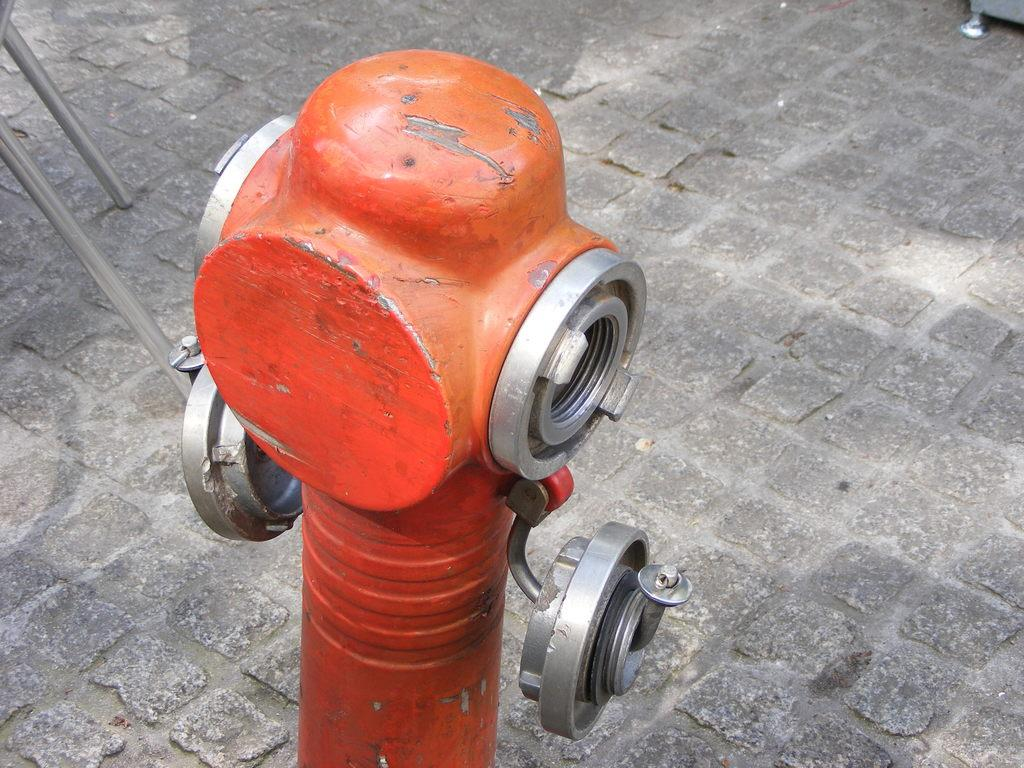Where was the image taken? The image was clicked outside. What is the prominent object in the foreground of the image? There is an orange color metal object in the foreground, which appears to be a water hydrant. What can be seen on the left side of the image? Metal rods are visible on the left side of the image. What type of surface is visible in the image? There is a pavement in the image. How many bodies are visible in the image? There are no bodies visible in the image; it primarily features a water hydrant, metal rods, and a pavement. 